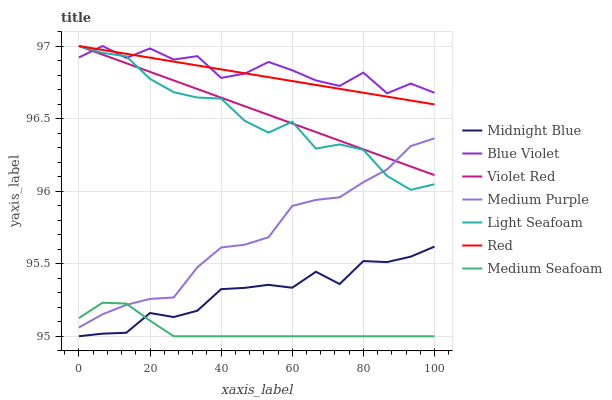Does Medium Seafoam have the minimum area under the curve?
Answer yes or no. Yes. Does Blue Violet have the maximum area under the curve?
Answer yes or no. Yes. Does Midnight Blue have the minimum area under the curve?
Answer yes or no. No. Does Midnight Blue have the maximum area under the curve?
Answer yes or no. No. Is Violet Red the smoothest?
Answer yes or no. Yes. Is Blue Violet the roughest?
Answer yes or no. Yes. Is Midnight Blue the smoothest?
Answer yes or no. No. Is Midnight Blue the roughest?
Answer yes or no. No. Does Midnight Blue have the lowest value?
Answer yes or no. Yes. Does Medium Purple have the lowest value?
Answer yes or no. No. Does Red have the highest value?
Answer yes or no. Yes. Does Midnight Blue have the highest value?
Answer yes or no. No. Is Medium Purple less than Red?
Answer yes or no. Yes. Is Violet Red greater than Midnight Blue?
Answer yes or no. Yes. Does Light Seafoam intersect Violet Red?
Answer yes or no. Yes. Is Light Seafoam less than Violet Red?
Answer yes or no. No. Is Light Seafoam greater than Violet Red?
Answer yes or no. No. Does Medium Purple intersect Red?
Answer yes or no. No. 